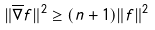<formula> <loc_0><loc_0><loc_500><loc_500>\| \overline { \nabla } f \| ^ { 2 } \geq ( n + 1 ) \| f \| ^ { 2 }</formula> 